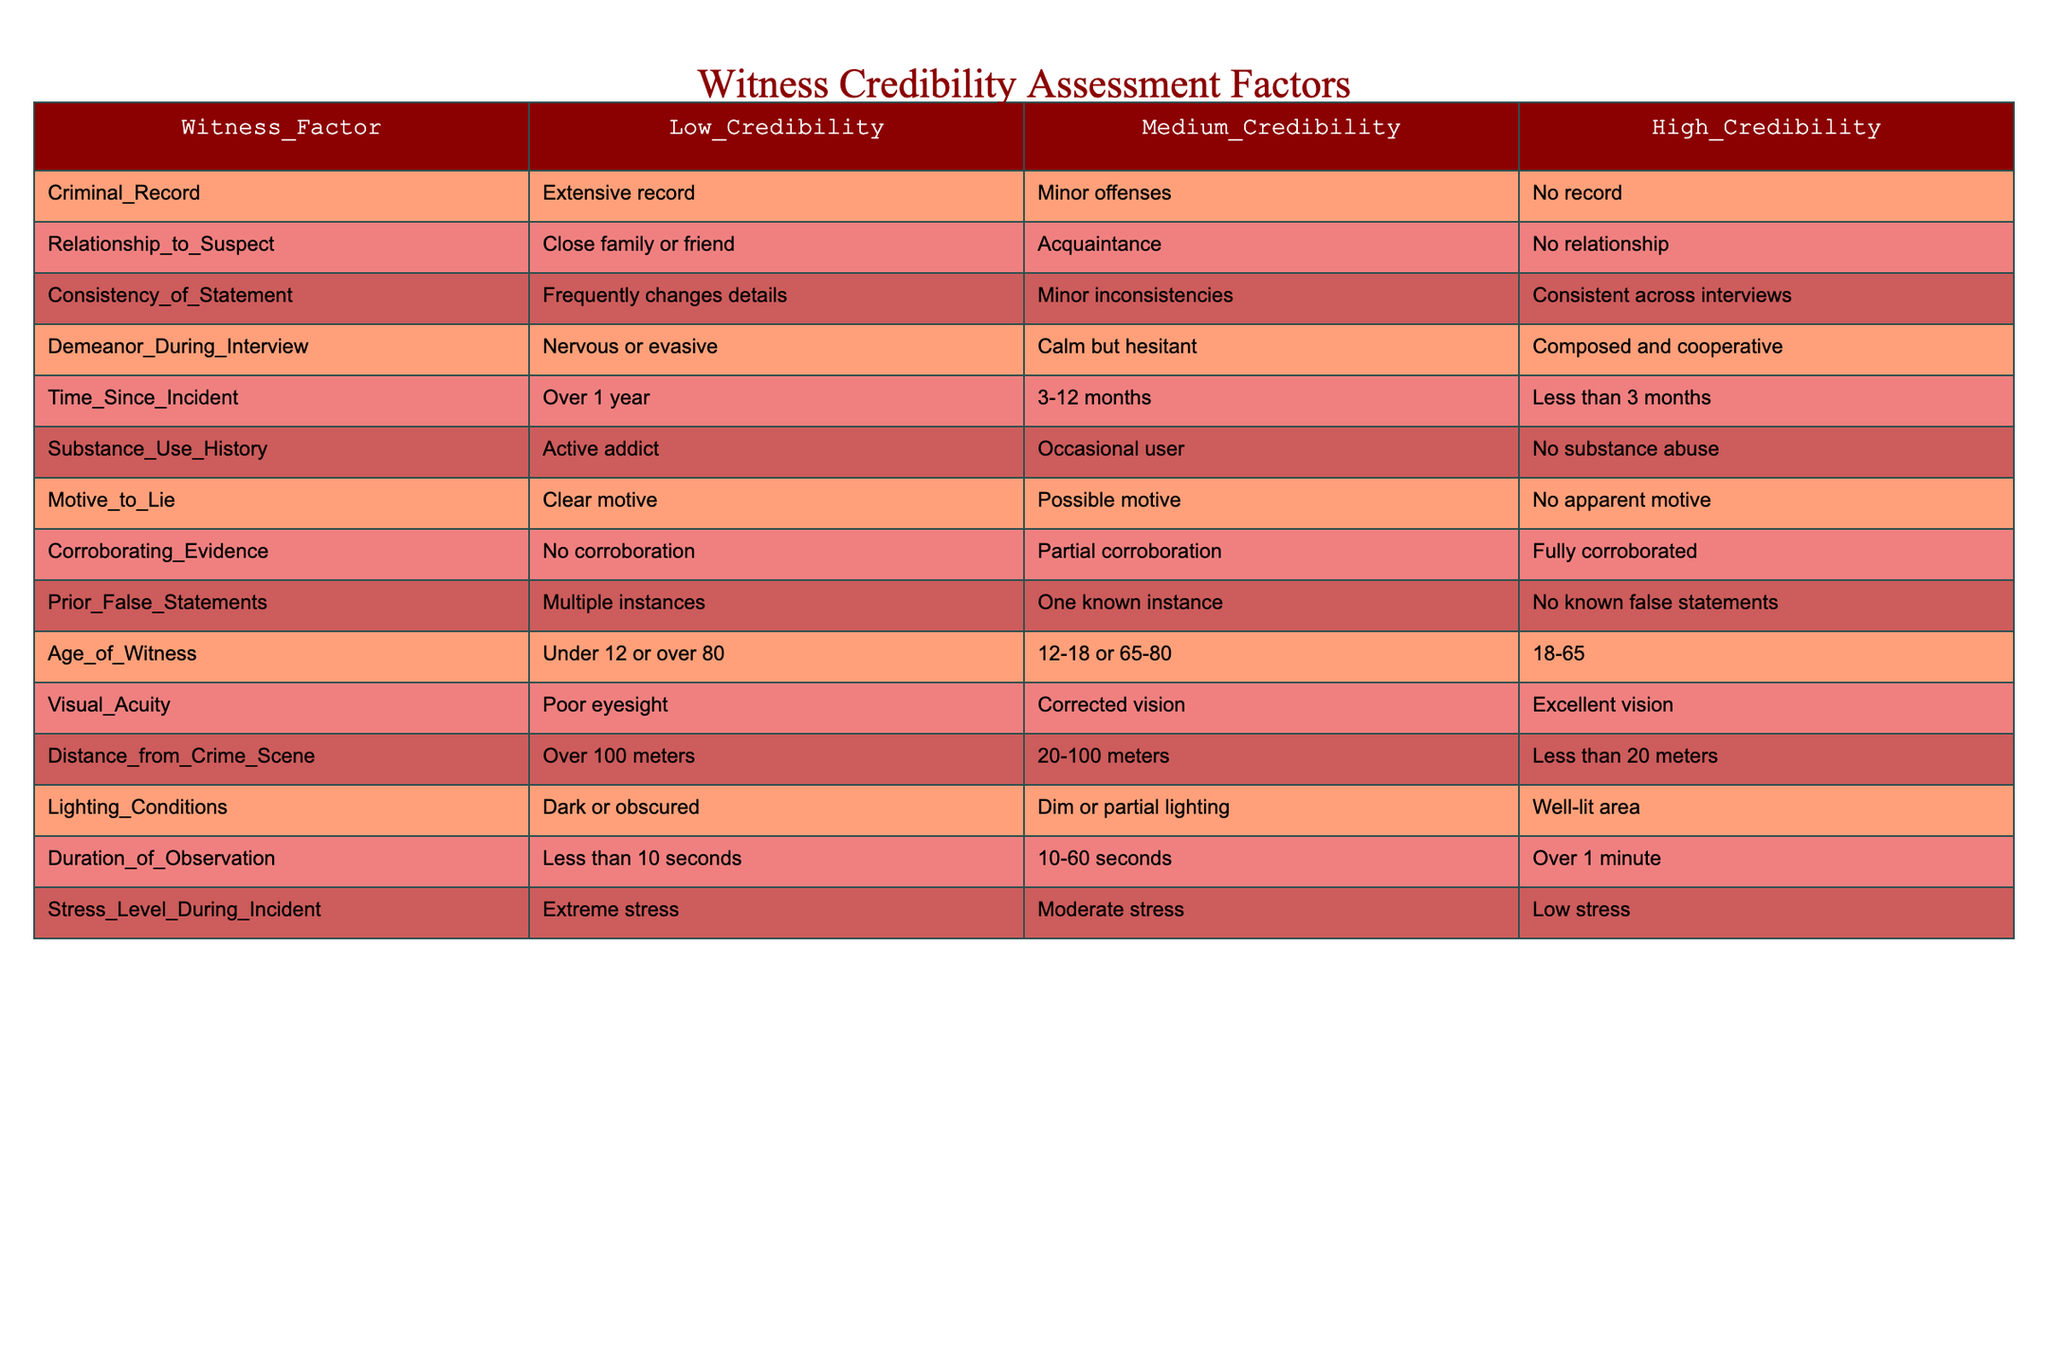What is the factor indicating low credibility of a witness with a criminal record? According to the table, a witness with a criminal record that has an extensive record is classified as having low credibility in this factor.
Answer: Extensive record What is the relationship between the witness’s age and their credibility? The table shows that witnesses who are under 12 or over 80 years old fall under low credibility, ages 12-18 or 65-80 are medium credibility, and those aged 18-65 hold high credibility.
Answer: High credibility for ages 18-65 Does a close relationship to the suspect affect witness credibility? Yes, the table indicates that a close family or friend relationship classifies a witness as low credibility, whereas having no relationship is categorized as high credibility.
Answer: Yes How many factors indicate high credibility for a witness? By counting the factors listed under the high credibility column, there are 8 factors indicating high credibility for a witness.
Answer: 8 If a witness has minor inconsistencies in their statement, what is their credibility level? The table indicates that minor inconsistencies in a witness's statement would place them in the medium credibility category.
Answer: Medium credibility Is the visibility condition important for witness credibility? Yes, the table suggests that well-lit areas contribute to high credibility for a witness, whereas dark conditions lower credibility.
Answer: Yes What are the stress levels indicating low credibility during the incident? According to the table, extreme stress levels during the incident classify a witness as low credibility.
Answer: Extreme stress If a witness has corroborating evidence, what credibility level do they have? The table indicates that if corroborating evidence is fully corroborated, the witness is classified as having high credibility.
Answer: High credibility 